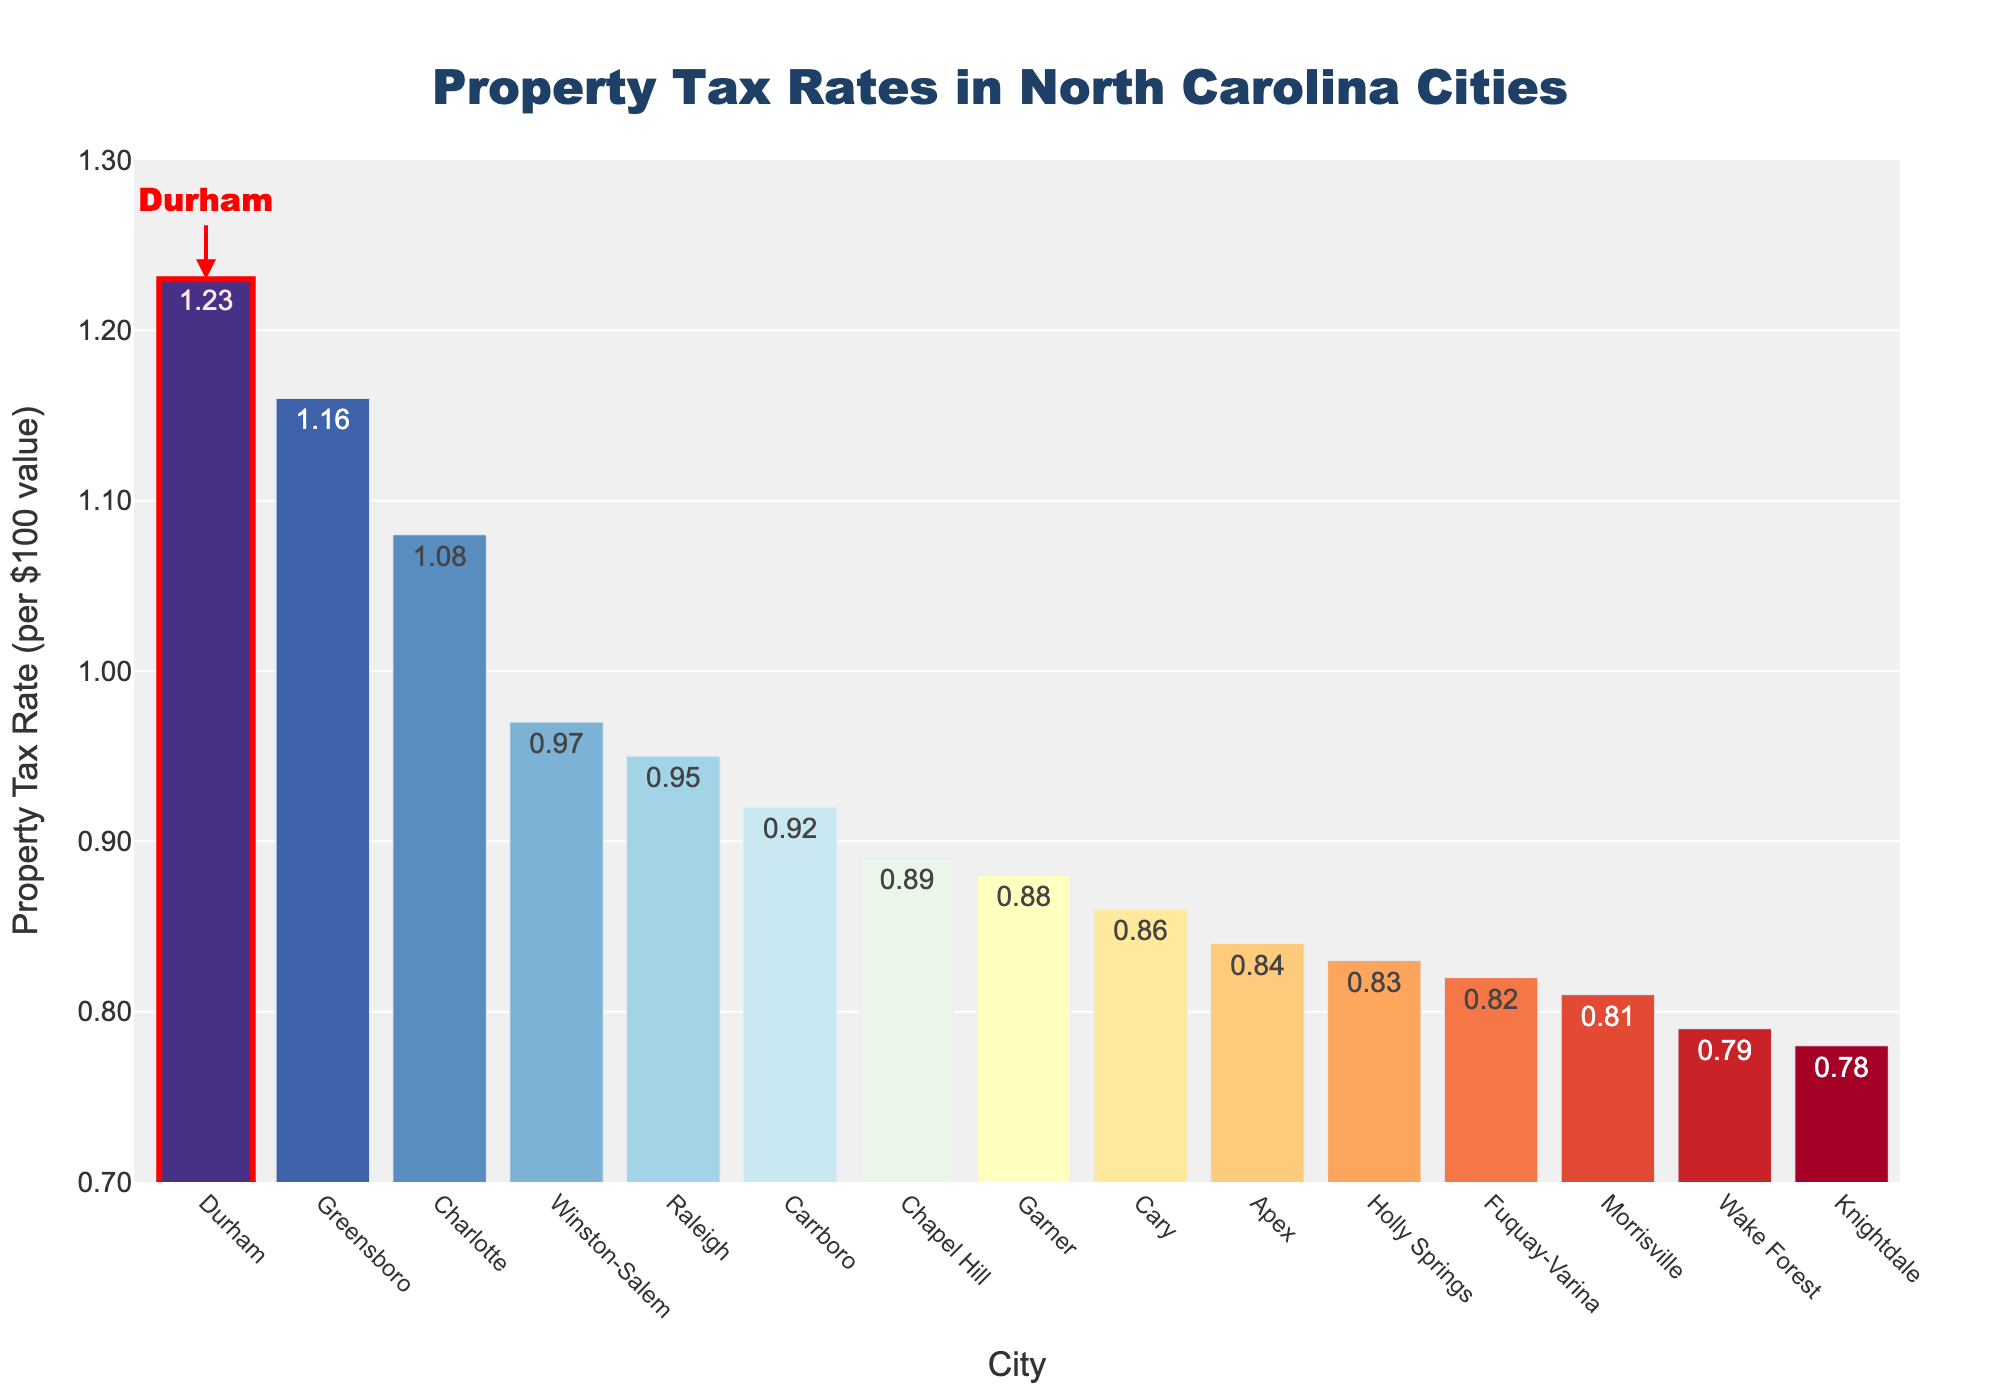Which city has the highest property tax rate? The bar chart shows the property tax rates of various cities sorted in descending order. The highest bar represents the city with the highest property tax rate, which is Durham.
Answer: Durham Which city has the lowest property tax rate? The bar chart shows the property tax rates of various cities sorted in descending order. The shortest bar represents the city with the lowest property tax rate, which is Knightdale.
Answer: Knightdale How does Durham's property tax rate compare to Raleigh's? Durham has a highlighted bar with a higher height compared to Raleigh's. The text on the bars indicates that Durham's property tax rate is 1.23, while Raleigh's is 0.95.
Answer: Durham's rate is higher Which city has a property tax rate closest to 1.00? The bar that visually aligns closest to the 1.00 mark is the one representing Winston-Salem, with a tax rate of 0.97.
Answer: Winston-Salem What is the difference in property tax rates between Durham and Cary? Durham's property tax rate is 1.23, and Cary's is 0.86. The difference is 1.23 - 0.86.
Answer: 0.37 What's the average property tax rate for all listed cities? Add all property tax rates and divide by the number of cities: (1.23 + 0.95 + 1.08 + 1.16 + 0.97 + 0.86 + 0.89 + 0.84 + 0.79 + 0.81 + 0.92 + 0.88 + 0.83 + 0.78 + 0.82) / 15.
Answer: 0.944 Is there any visual indication highlighting Durham? Yes, Durham is visually marked with a rectangle shape filled in light red and has a red arrow annotation pointing at it.
Answer: Yes Which two cities besides Durham have property tax rates above 1.10? By observing the bars with rates above the 1.10 mark, we identify Charlotte and Greensboro.
Answer: Charlotte, Greensboro How many cities have property tax rates below 0.90? Count the bars that fall below the 0.90 mark: Apex, Wake Forest, Morrisville, Holly Springs, Knightdale, Fuquay-Varina, and Cary.
Answer: 7 Compare the property tax rates of Charlotte and Chapel Hill. By observing the height of the bars, Charlotte's bar (1.08) is taller than Chapel Hill's bar (0.89).
Answer: Charlotte's rate is higher 